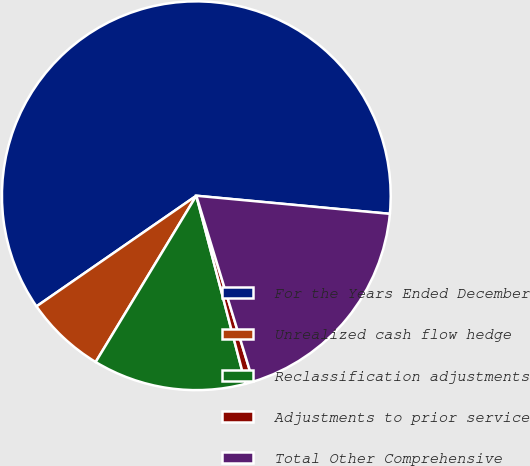<chart> <loc_0><loc_0><loc_500><loc_500><pie_chart><fcel>For the Years Ended December<fcel>Unrealized cash flow hedge<fcel>Reclassification adjustments<fcel>Adjustments to prior service<fcel>Total Other Comprehensive<nl><fcel>61.12%<fcel>6.7%<fcel>12.74%<fcel>0.65%<fcel>18.79%<nl></chart> 